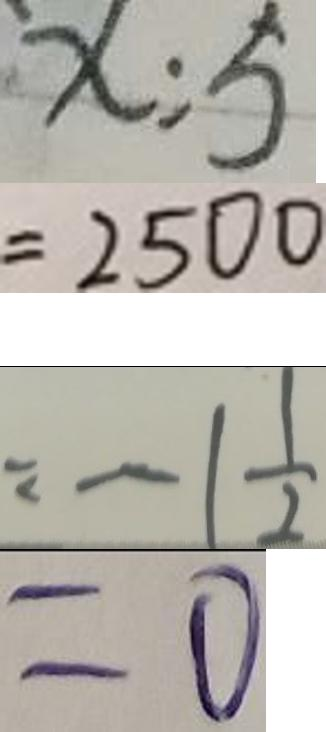<formula> <loc_0><loc_0><loc_500><loc_500>x : 5 
 = 2 5 0 0 
 = - 1 \frac { 1 } { 2 } 
 = 0</formula> 